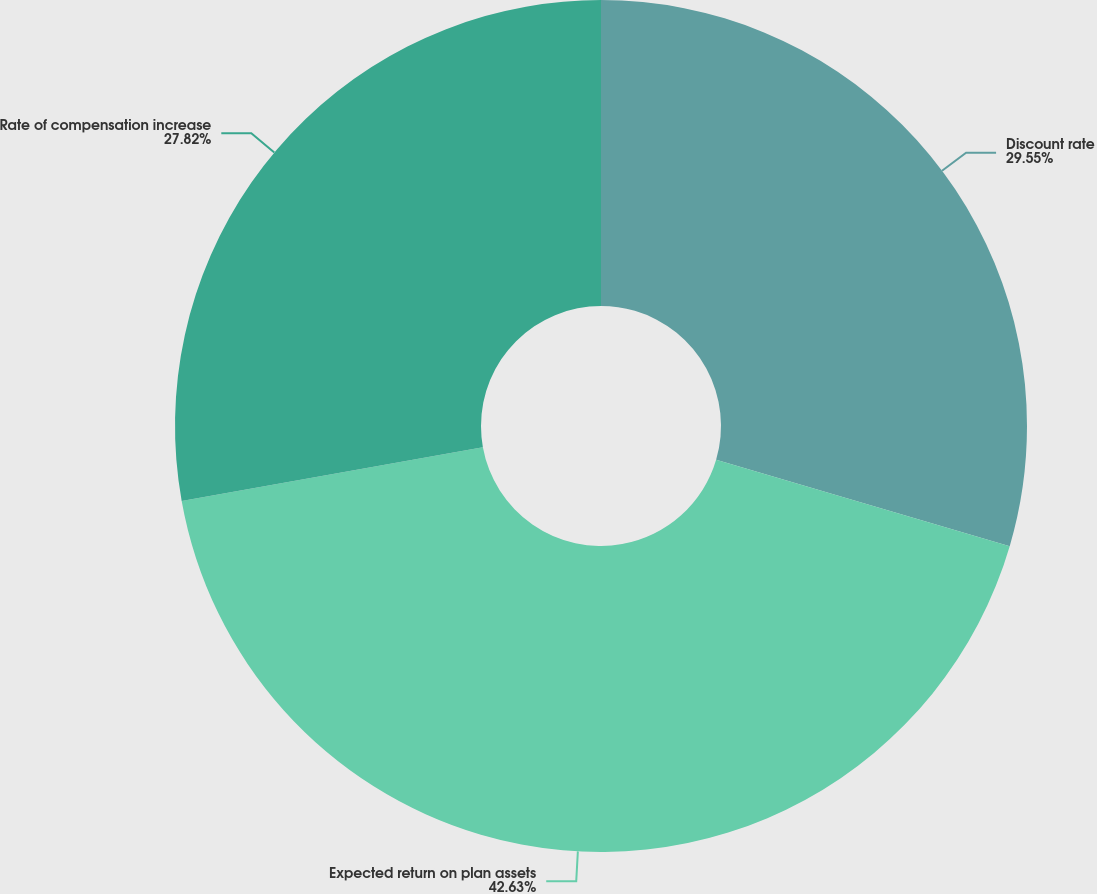<chart> <loc_0><loc_0><loc_500><loc_500><pie_chart><fcel>Discount rate<fcel>Expected return on plan assets<fcel>Rate of compensation increase<nl><fcel>29.55%<fcel>42.63%<fcel>27.82%<nl></chart> 